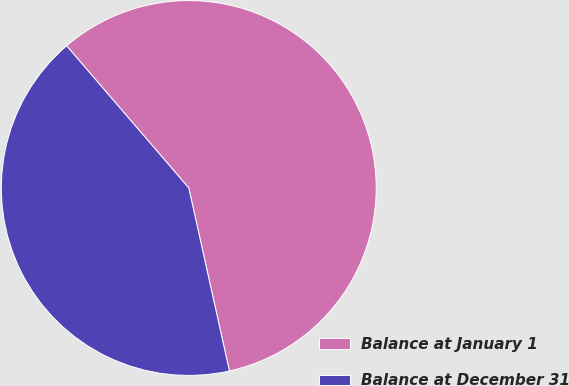<chart> <loc_0><loc_0><loc_500><loc_500><pie_chart><fcel>Balance at January 1<fcel>Balance at December 31<nl><fcel>57.82%<fcel>42.18%<nl></chart> 